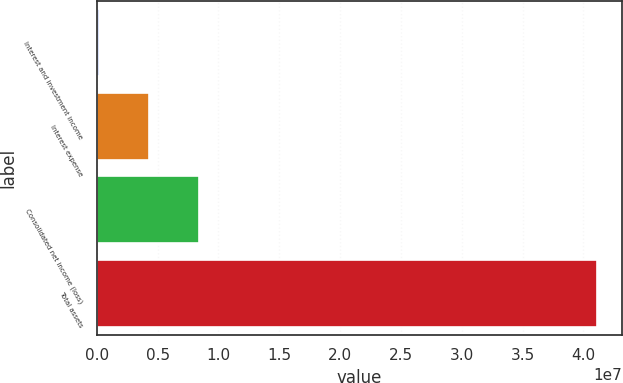Convert chart to OTSL. <chart><loc_0><loc_0><loc_500><loc_500><bar_chart><fcel>Interest and investment income<fcel>Interest expense<fcel>Consolidated net income (loss)<fcel>Total assets<nl><fcel>189994<fcel>4.28087e+06<fcel>8.37175e+06<fcel>4.10988e+07<nl></chart> 